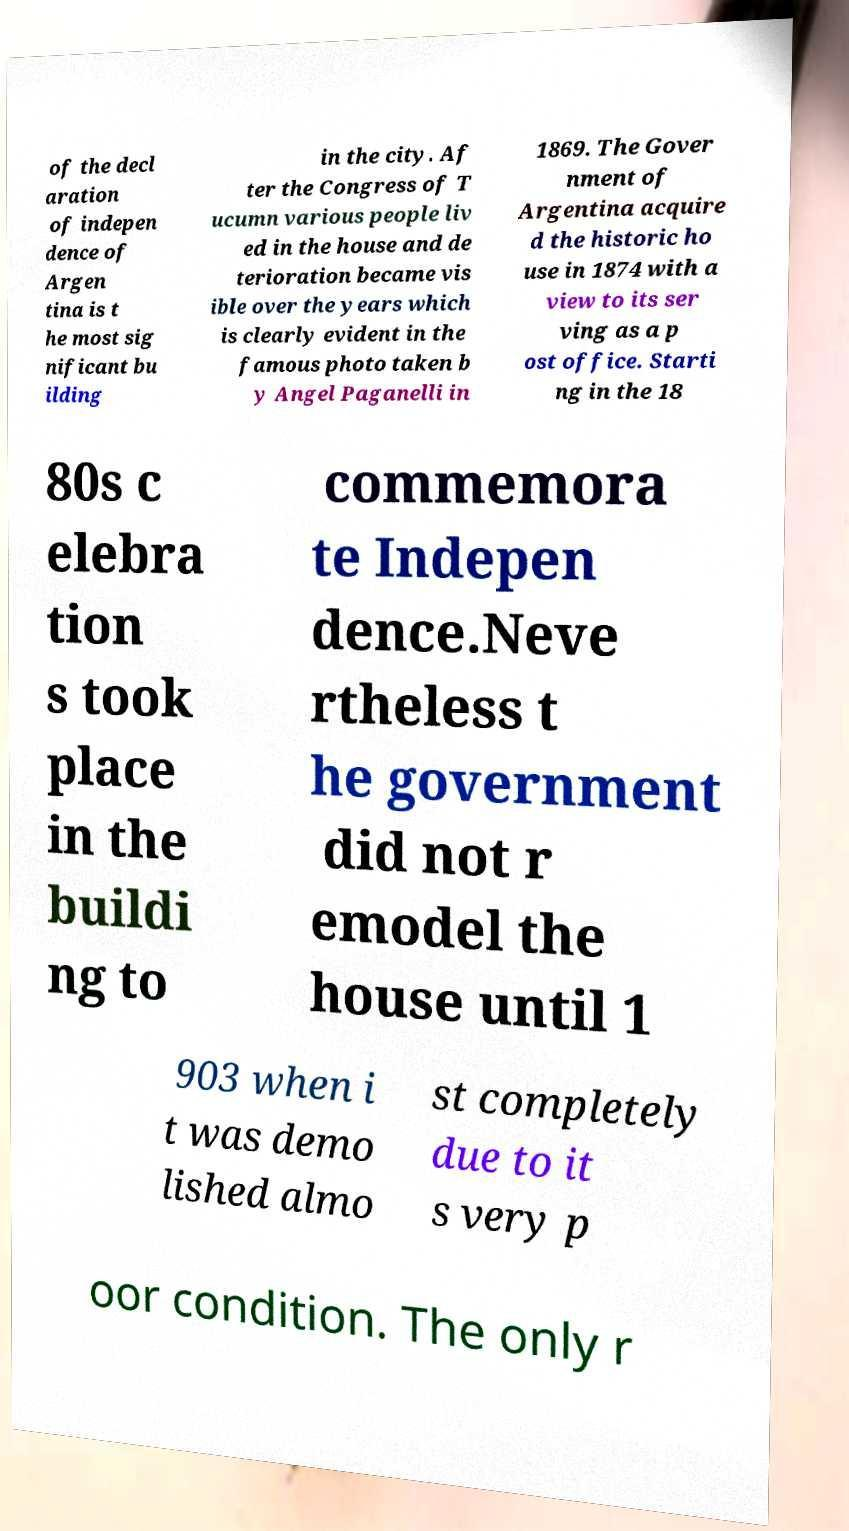I need the written content from this picture converted into text. Can you do that? of the decl aration of indepen dence of Argen tina is t he most sig nificant bu ilding in the city. Af ter the Congress of T ucumn various people liv ed in the house and de terioration became vis ible over the years which is clearly evident in the famous photo taken b y Angel Paganelli in 1869. The Gover nment of Argentina acquire d the historic ho use in 1874 with a view to its ser ving as a p ost office. Starti ng in the 18 80s c elebra tion s took place in the buildi ng to commemora te Indepen dence.Neve rtheless t he government did not r emodel the house until 1 903 when i t was demo lished almo st completely due to it s very p oor condition. The only r 